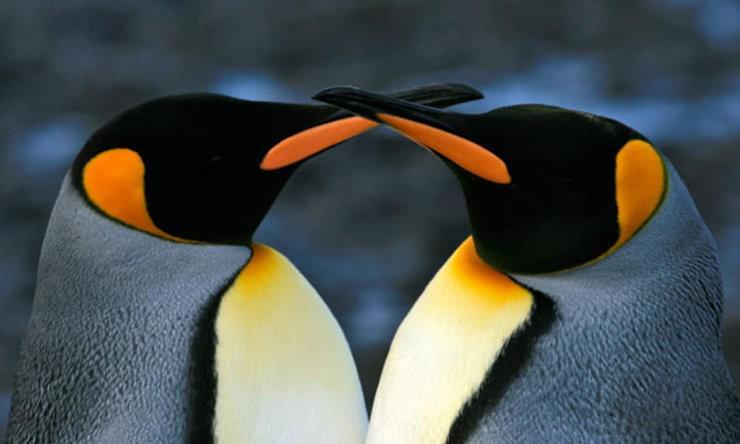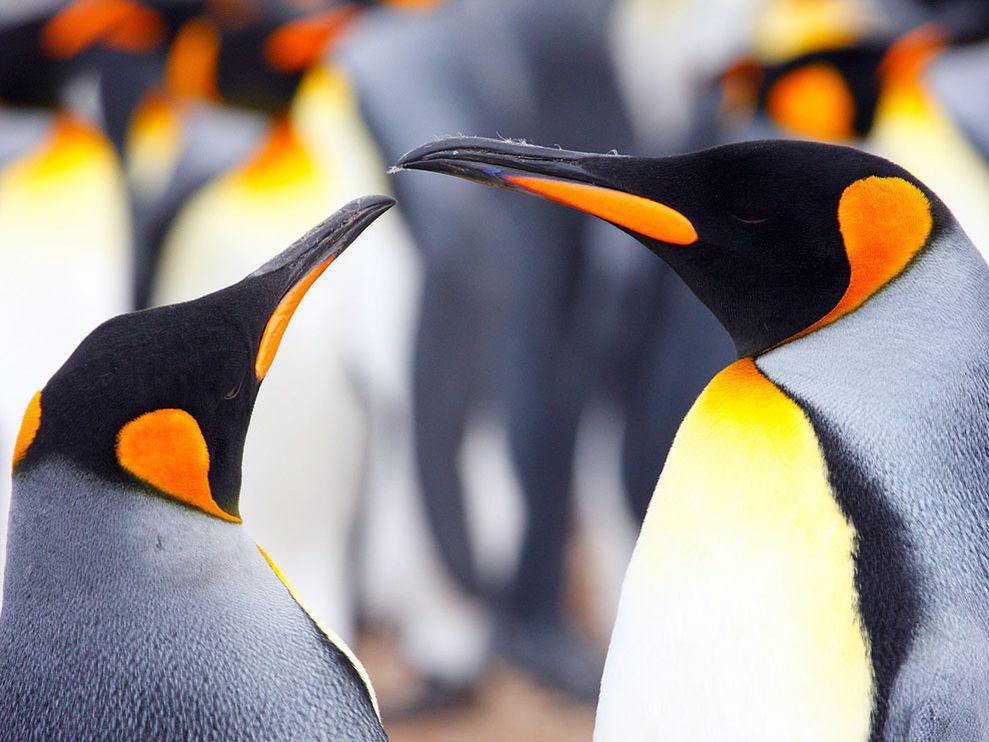The first image is the image on the left, the second image is the image on the right. Evaluate the accuracy of this statement regarding the images: "In one image there is a pair of penguins nuzzling each others' beak.". Is it true? Answer yes or no. Yes. The first image is the image on the left, the second image is the image on the right. Analyze the images presented: Is the assertion "There are at least 4 penguins and none of them has a small baby alongside them." valid? Answer yes or no. Yes. 